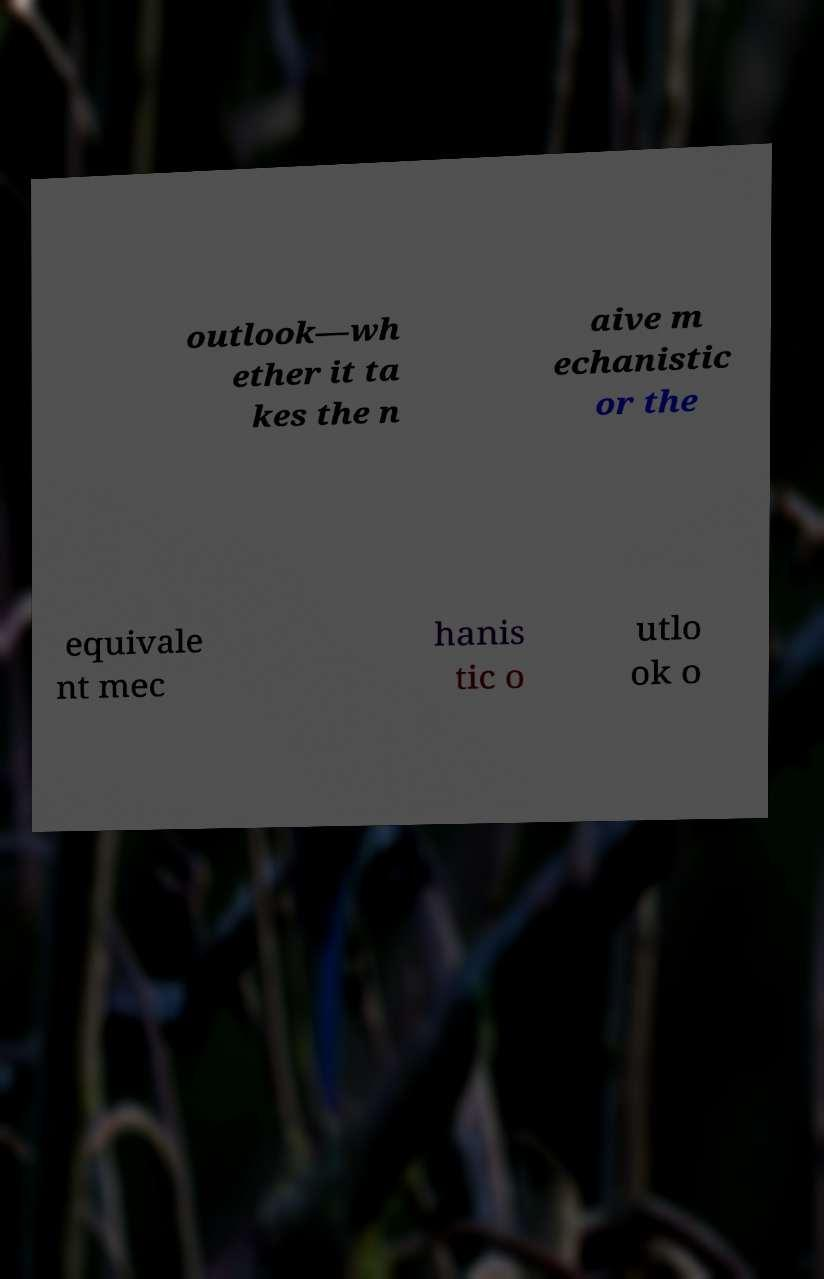What messages or text are displayed in this image? I need them in a readable, typed format. outlook—wh ether it ta kes the n aive m echanistic or the equivale nt mec hanis tic o utlo ok o 